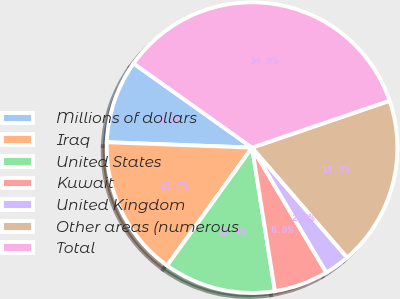<chart> <loc_0><loc_0><loc_500><loc_500><pie_chart><fcel>Millions of dollars<fcel>Iraq<fcel>United States<fcel>Kuwait<fcel>United Kingdom<fcel>Other areas (numerous<fcel>Total<nl><fcel>9.24%<fcel>15.66%<fcel>12.45%<fcel>6.02%<fcel>2.81%<fcel>18.88%<fcel>34.94%<nl></chart> 